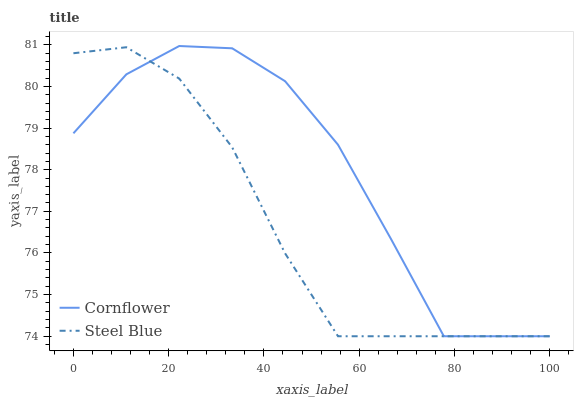Does Steel Blue have the minimum area under the curve?
Answer yes or no. Yes. Does Cornflower have the maximum area under the curve?
Answer yes or no. Yes. Does Steel Blue have the maximum area under the curve?
Answer yes or no. No. Is Steel Blue the smoothest?
Answer yes or no. Yes. Is Cornflower the roughest?
Answer yes or no. Yes. Is Steel Blue the roughest?
Answer yes or no. No. Does Cornflower have the lowest value?
Answer yes or no. Yes. Does Cornflower have the highest value?
Answer yes or no. Yes. Does Steel Blue have the highest value?
Answer yes or no. No. Does Cornflower intersect Steel Blue?
Answer yes or no. Yes. Is Cornflower less than Steel Blue?
Answer yes or no. No. Is Cornflower greater than Steel Blue?
Answer yes or no. No. 